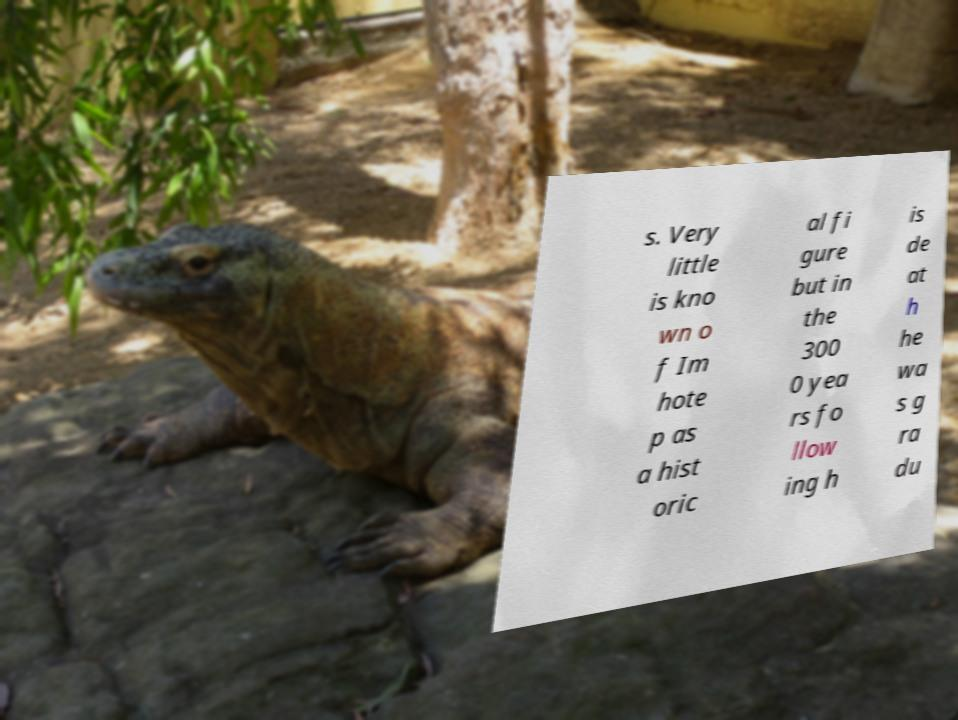Could you assist in decoding the text presented in this image and type it out clearly? s. Very little is kno wn o f Im hote p as a hist oric al fi gure but in the 300 0 yea rs fo llow ing h is de at h he wa s g ra du 